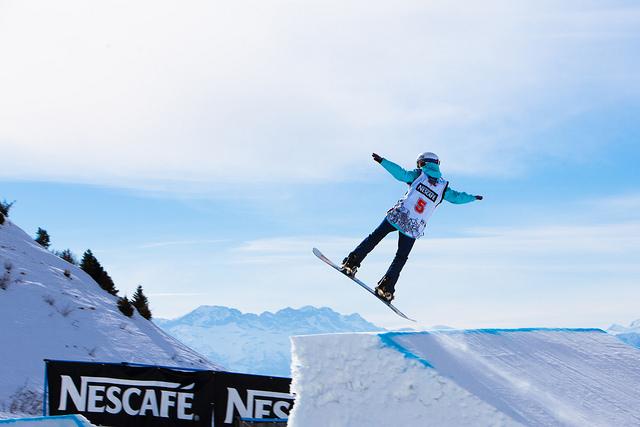Is the man flying?
Concise answer only. No. What does the banner say?
Give a very brief answer. Nescafe. Is it cold here?
Write a very short answer. Yes. 